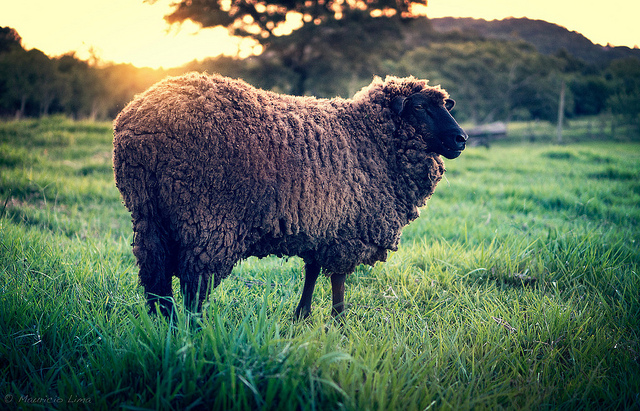Based on the scene, what might be a plausible reason for the sheep being in this location? The sheep is in a lush, open field, typical for grazing. Sheep are herbivores that primarily feed on grass. The vast open space and rich grass suggest this could be a pasture where the sheep can graze freely. Farmers often allow sheep to roam in such fields to ensure they receive a natural diet, which can improve wool quality and overall health. So, a plausible reason for the sheep being here is for grazing. 